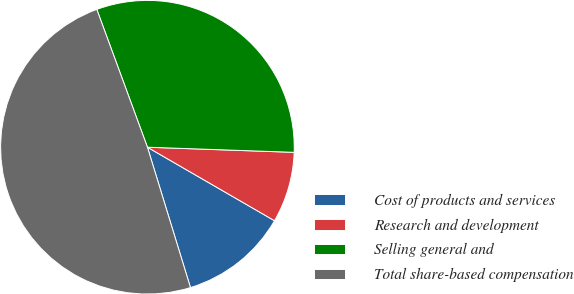<chart> <loc_0><loc_0><loc_500><loc_500><pie_chart><fcel>Cost of products and services<fcel>Research and development<fcel>Selling general and<fcel>Total share-based compensation<nl><fcel>11.92%<fcel>7.79%<fcel>31.16%<fcel>49.13%<nl></chart> 